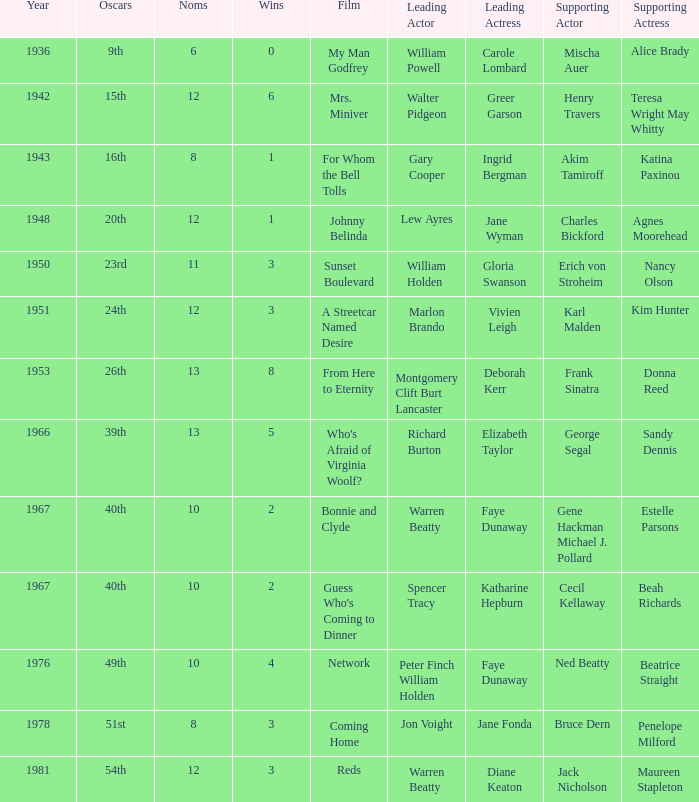Who was the secondary actress in 1943? Katina Paxinou. 